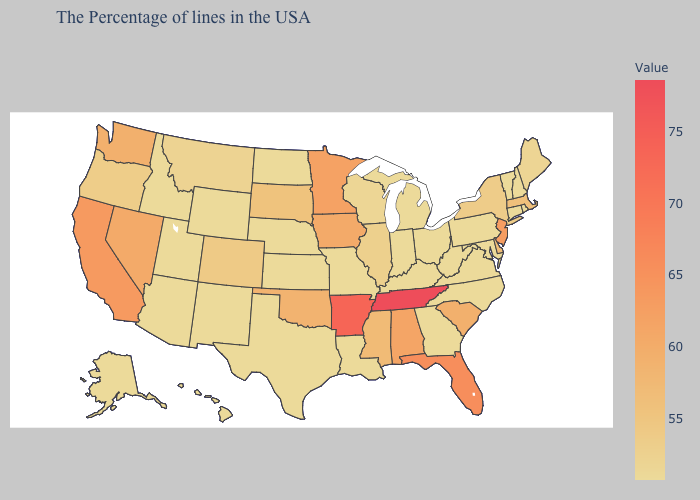Does California have the highest value in the West?
Keep it brief. Yes. Does Massachusetts have a lower value than Minnesota?
Keep it brief. Yes. Which states have the lowest value in the West?
Short answer required. Wyoming, New Mexico, Utah, Arizona, Idaho, Alaska, Hawaii. 